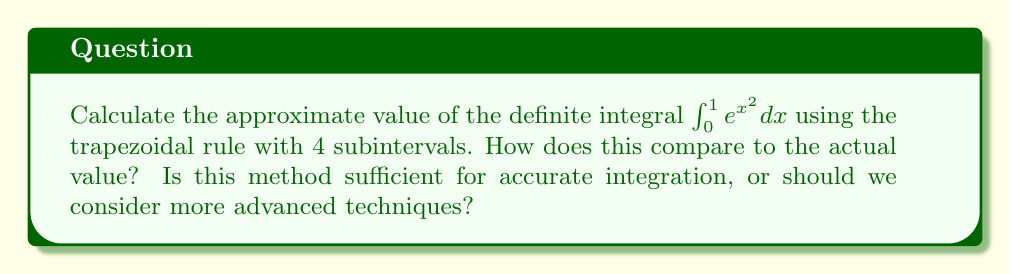Show me your answer to this math problem. Let's approach this step-by-step:

1) The trapezoidal rule for n subintervals is given by:

   $$\int_{a}^{b} f(x) dx \approx \frac{h}{2}[f(x_0) + 2f(x_1) + 2f(x_2) + ... + 2f(x_{n-1}) + f(x_n)]$$

   where $h = \frac{b-a}{n}$ and $x_i = a + ih$ for $i = 0, 1, ..., n$

2) In our case, $a=0$, $b=1$, $n=4$, and $f(x) = e^{x^2}$

3) Calculate $h$:
   $h = \frac{1-0}{4} = 0.25$

4) Calculate the x-values:
   $x_0 = 0$
   $x_1 = 0.25$
   $x_2 = 0.5$
   $x_3 = 0.75$
   $x_4 = 1$

5) Calculate the corresponding f(x) values:
   $f(x_0) = e^{0^2} = 1$
   $f(x_1) = e^{0.25^2} \approx 1.0645$
   $f(x_2) = e^{0.5^2} \approx 1.2840$
   $f(x_3) = e^{0.75^2} \approx 1.7537$
   $f(x_4) = e^{1^2} = e \approx 2.7183$

6) Apply the trapezoidal rule:
   $$\frac{0.25}{2}[1 + 2(1.0645) + 2(1.2840) + 2(1.7537) + 2.7183] \approx 1.4645$$

7) The actual value of this integral is approximately 1.4626, which can be calculated using more advanced methods or symbolic integration.

8) The error in this approximation is about 0.0019 or 0.13%.

While this method provides a reasonable approximation, more advanced techniques like Simpson's rule or adaptive quadrature methods could provide better accuracy, especially for more complex functions. However, the simplicity of the trapezoidal rule makes it a good starting point for many applications.
Answer: 1.4645 